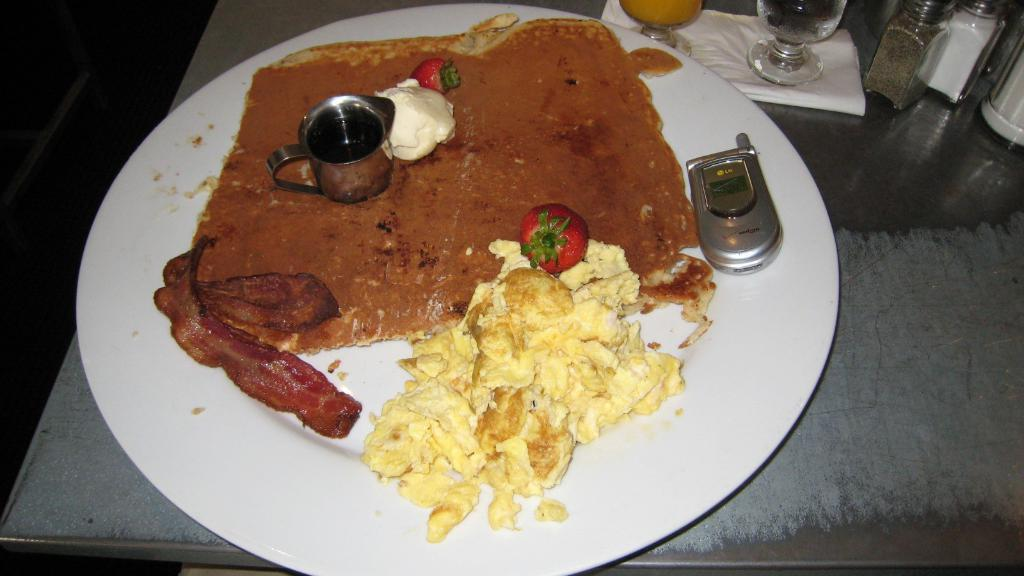What piece of furniture is visible in the image? There is a table in the image. What is on the table? There is a serving plate with food on the table, as well as a mobile phone and glass tumblers. How are the glass tumblers arranged on the table? The glass tumblers are placed on a paper napkin. What else can be seen in the image? There are sprinklers in the image. What type of pancake is being smashed by the person laughing in the image? There is no person laughing or pancake being smashed in the image. 